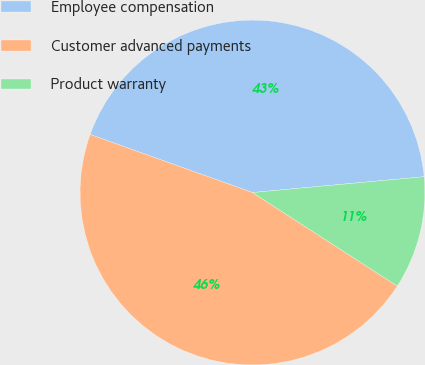<chart> <loc_0><loc_0><loc_500><loc_500><pie_chart><fcel>Employee compensation<fcel>Customer advanced payments<fcel>Product warranty<nl><fcel>43.07%<fcel>46.34%<fcel>10.59%<nl></chart> 